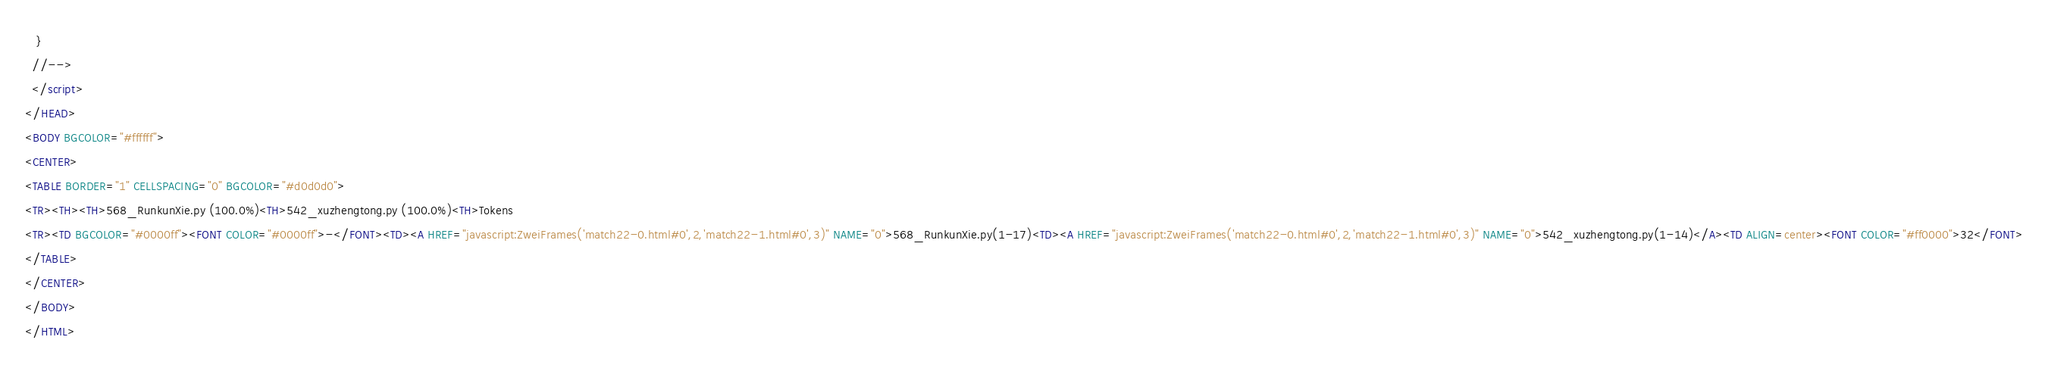<code> <loc_0><loc_0><loc_500><loc_500><_HTML_>   }
  //-->
  </script>
</HEAD>
<BODY BGCOLOR="#ffffff">
<CENTER>
<TABLE BORDER="1" CELLSPACING="0" BGCOLOR="#d0d0d0">
<TR><TH><TH>568_RunkunXie.py (100.0%)<TH>542_xuzhengtong.py (100.0%)<TH>Tokens
<TR><TD BGCOLOR="#0000ff"><FONT COLOR="#0000ff">-</FONT><TD><A HREF="javascript:ZweiFrames('match22-0.html#0',2,'match22-1.html#0',3)" NAME="0">568_RunkunXie.py(1-17)<TD><A HREF="javascript:ZweiFrames('match22-0.html#0',2,'match22-1.html#0',3)" NAME="0">542_xuzhengtong.py(1-14)</A><TD ALIGN=center><FONT COLOR="#ff0000">32</FONT>
</TABLE>
</CENTER>
</BODY>
</HTML>

</code> 